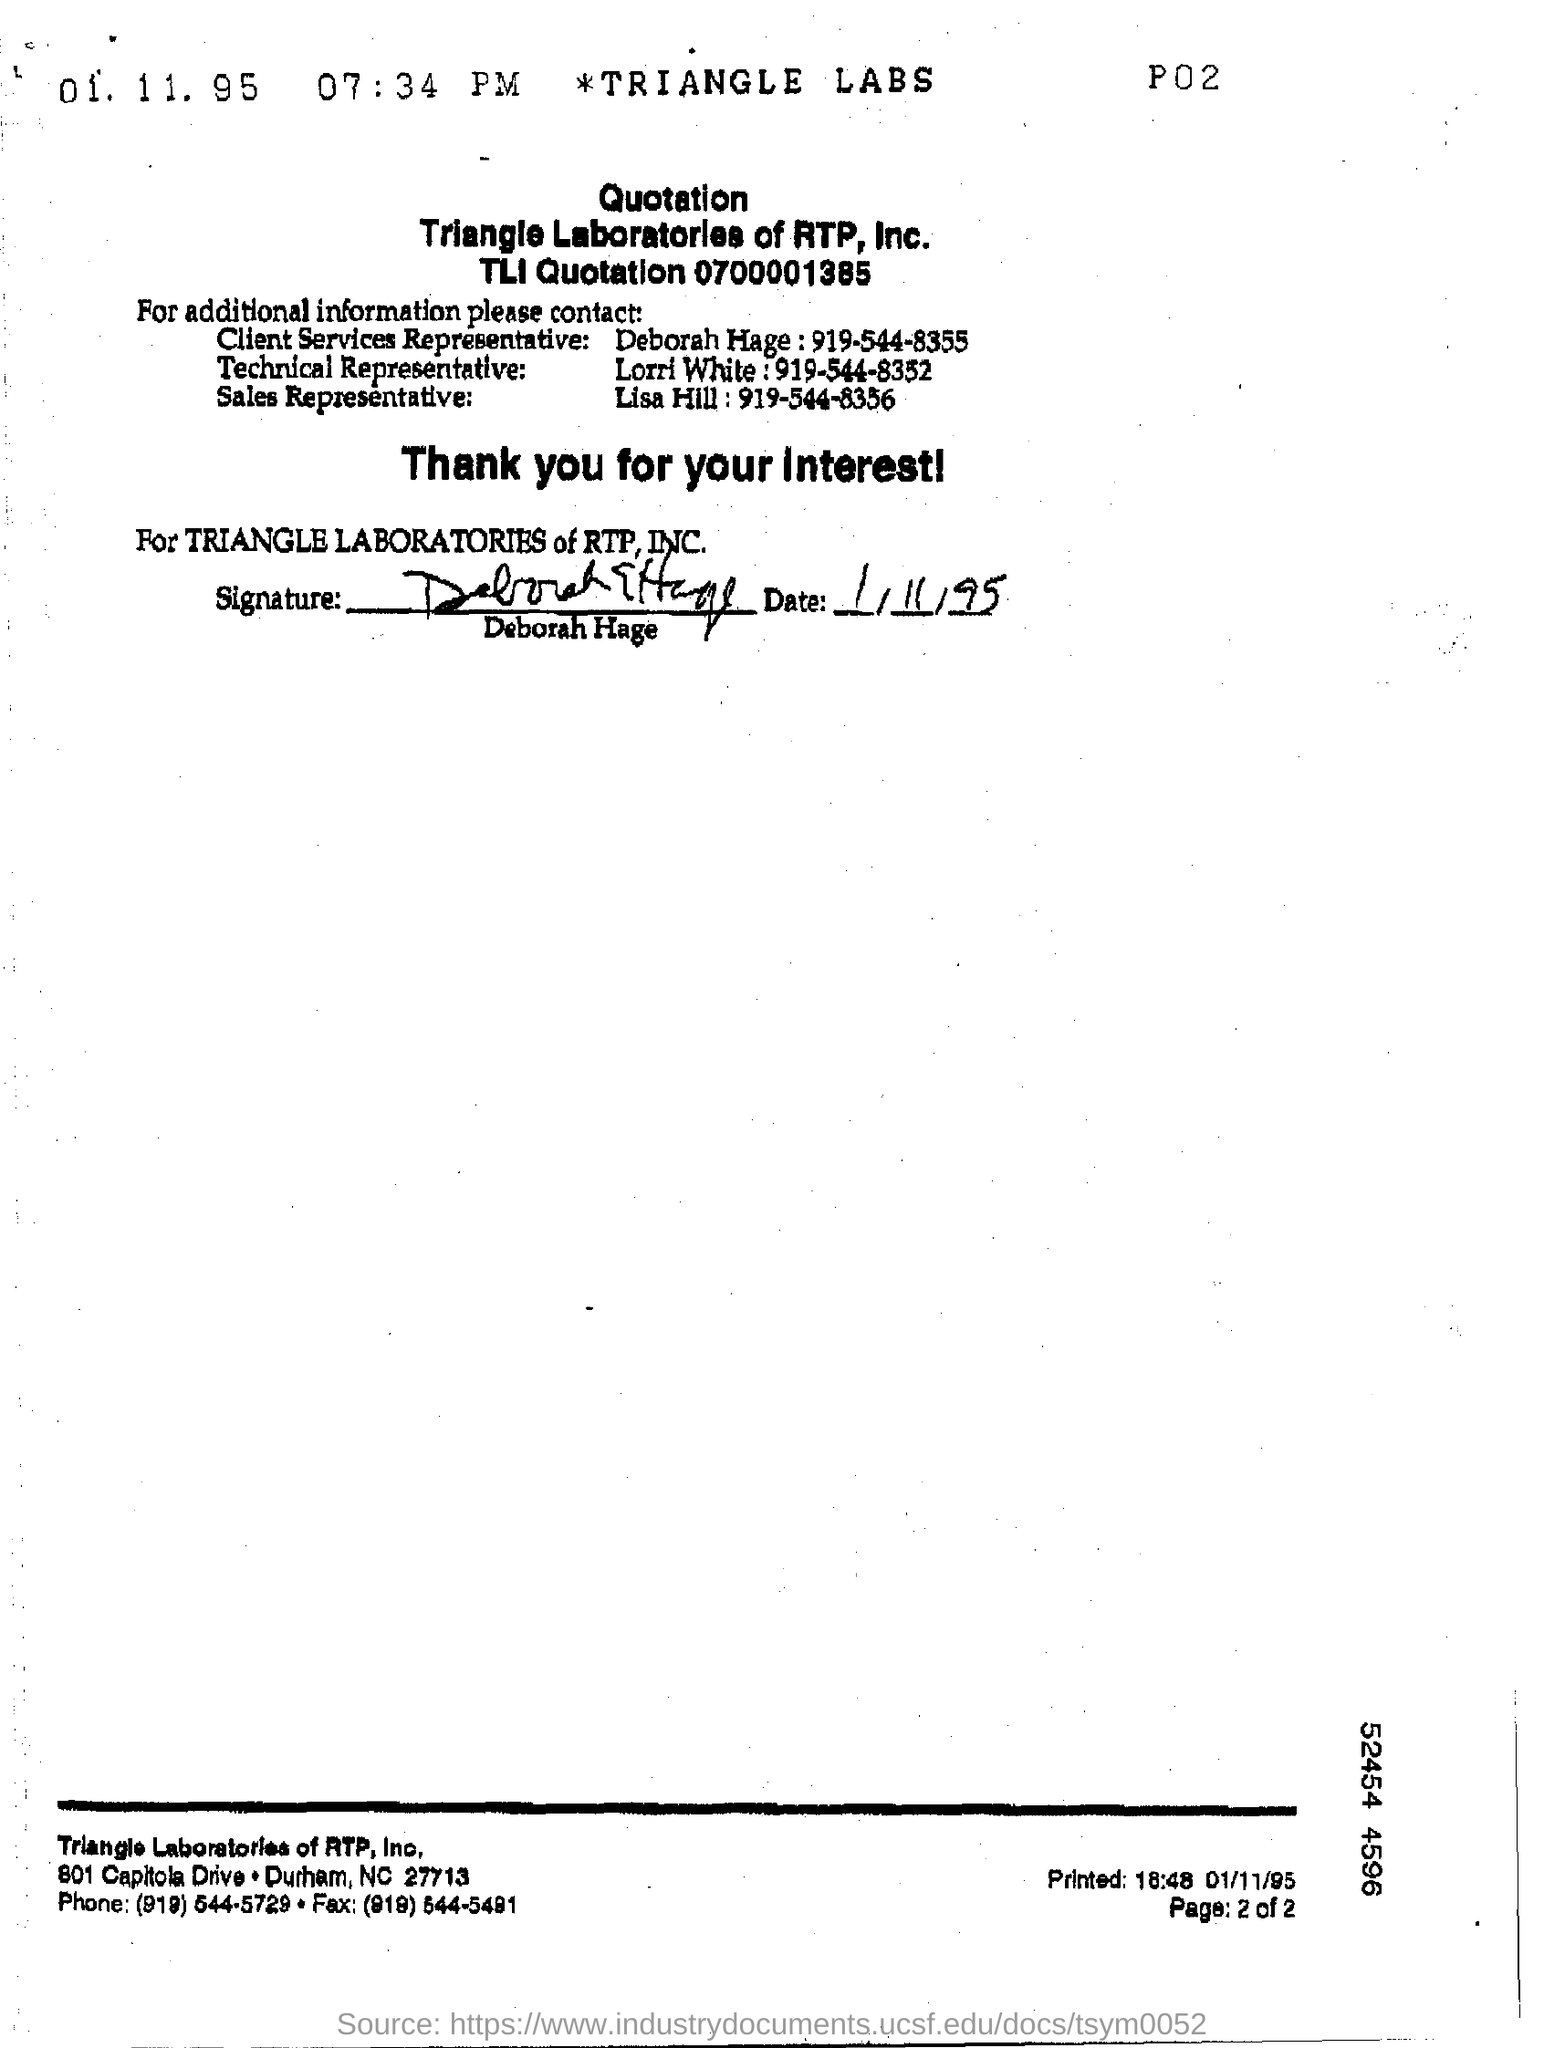Point out several critical features in this image. Deborah Hage is the client services representative. The company that sent the quotation is Triangle Laboratories of RTP, Inc. Lorri White is the technical representative. The sales representative is Lisa Hill. 